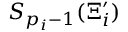<formula> <loc_0><loc_0><loc_500><loc_500>S _ { p _ { i } - 1 } ( \Xi _ { i } ^ { \prime } )</formula> 